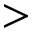Convert formula to latex. <formula><loc_0><loc_0><loc_500><loc_500>></formula> 